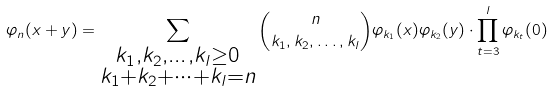<formula> <loc_0><loc_0><loc_500><loc_500>\varphi _ { n } ( x + y ) = \sum _ { \substack { k _ { 1 } , k _ { 2 } , \dots , k _ { l } \geq 0 \\ k _ { 1 } + k _ { 2 } + \cdots + k _ { l } = n } } \binom { n } { k _ { 1 } , k _ { 2 } , \dots , k _ { l } } \varphi _ { k _ { 1 } } ( x ) \varphi _ { k _ { 2 } } ( y ) \cdot \prod _ { t = 3 } ^ { l } \varphi _ { k _ { t } } ( 0 )</formula> 